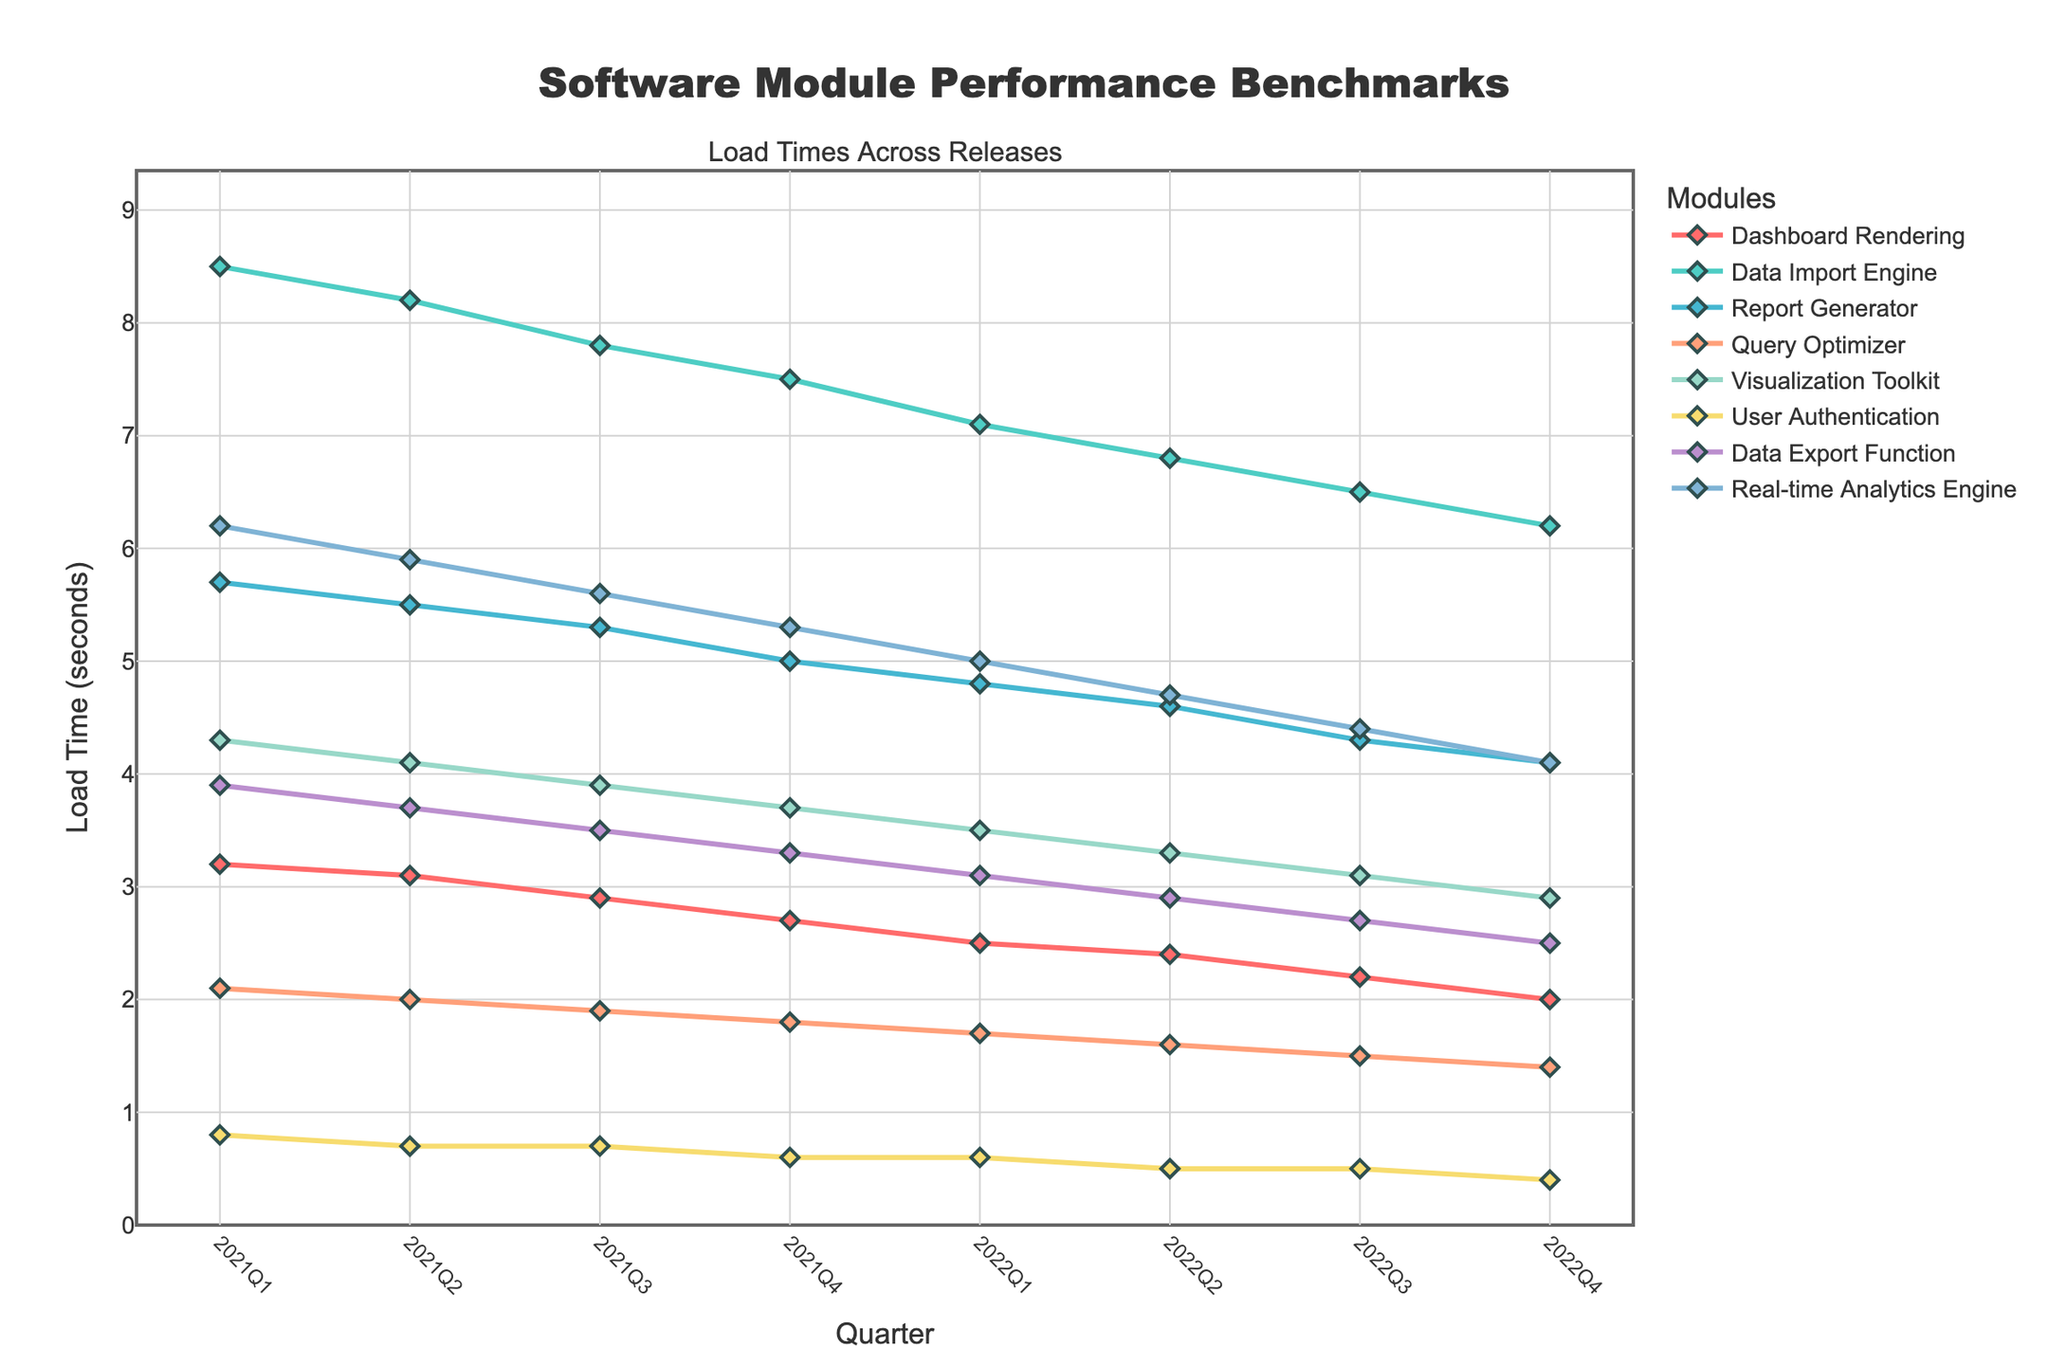What's the trend in load times for the Dashboard Rendering module over the given quarters? By observing the line and markers for the Dashboard Rendering module, you see a decreasing trend in load times from 2021Q1 to 2022Q4. The values decrease from 3.2 seconds in 2021Q1 to 2.0 seconds in 2022Q4.
Answer: Decreasing Which module had the highest load time in 2021Q1 and what was the load time? By looking at the highest point in the 2021Q1 section of the graph, the Data Import Engine module had the highest load time of 8.5 seconds.
Answer: Data Import Engine, 8.5 seconds Compare the performance improvement between the Report Generator and the Query Optimizer modules from 2021Q1 to 2022Q4. The Report Generator improved from 5.7 seconds to 4.1 seconds, a reduction of 1.6 seconds. The Query Optimizer improved from 2.1 seconds to 1.4 seconds, a reduction of 0.7 seconds. Thus, the Report Generator had a larger performance improvement.
Answer: Report Generator What are the load times for the Visualization Toolkit in 2021Q2 and 2022Q4? For the Visualization Toolkit, the load times are at the respective points in 2021Q2 and 2022Q4: 4.1 seconds and 2.9 seconds.
Answer: 4.1 seconds and 2.9 seconds Identify the module with the least improvement in load time from 2021Q1 to 2022Q4. Comparing the differences in load times across all modules from 2021Q1 to 2022Q4 shows that the User Authentication module had the least improvement, going from 0.8 to 0.4 seconds, an improvement of just 0.4 seconds.
Answer: User Authentication How does the load time of Real-time Analytics Engine in 2022Q2 compare to Data Export Function in the same quarter? In 2022Q2, from the corresponding points on their lines, the Real-time Analytics Engine's load time is 4.7 seconds, whereas the Data Export Function's load time is 2.9 seconds.
Answer: Higher for Real-time Analytics Engine Calculate the average load time for the Data Import Engine across all given quarters. Adding the Data Import Engine's load times across all quarters (8.5, 8.2, 7.8, 7.5, 7.1, 6.8, 6.5, 6.2) gives a total of 58.6. Dividing by the 8 quarters, the average load time is 7.325 seconds.
Answer: 7.325 seconds Which module showed the most consistent decrease in load time across the quarters? The Dashboard Rendering module shows a consistent decrease in load time as each quarter's load time is lower than the previous quarter (3.2, 3.1, 2.9, 2.7, 2.5, 2.4, 2.2, 2.0).
Answer: Dashboard Rendering Out of the modules listed, which had the second fastest load time in 2022Q4? In 2022Q4, the modules' load times, sorted from fastest to slowest, show that User Authentication (0.4 seconds) is the fastest and Query Optimizer (1.4 seconds) has the second fastest load time.
Answer: Query Optimizer 